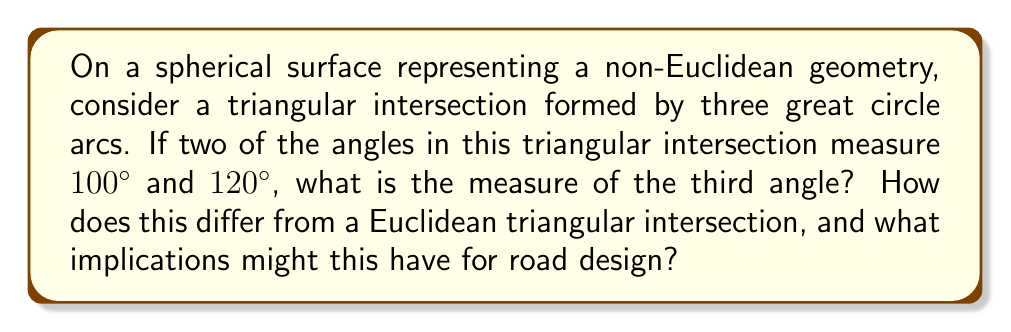Show me your answer to this math problem. Let's approach this step-by-step:

1) In spherical geometry, the sum of angles in a triangle is always greater than 180°. The formula for the angle sum of a spherical triangle is:

   $$ \text{Angle Sum} = 180° + A $$

   where $A$ is the area of the triangle in steradians multiplied by $\frac{180°}{\pi}$.

2) Let's denote the unknown angle as $x$. We know that:

   $$ 100° + 120° + x > 180° $$

3) In fact, we can calculate $x$ precisely. The angle sum formula for a spherical triangle is:

   $$ 100° + 120° + x = 180° + A $$

4) Simplifying:

   $$ 220° + x = 180° + A $$
   $$ x = (180° + A) - 220° = A - 40° $$

5) The exact value of $A$ depends on the size of the triangle on the sphere. However, we know that $A > 0°$, so:

   $$ x > -40° $$

6) Since angles must be positive, we can conclude that:

   $$ x > 0° $$

7) This means that the third angle must be positive, and the sum of the three angles will exceed 180°.

8) In contrast, in Euclidean geometry, the sum of angles in a triangle is always exactly 180°. If this were a Euclidean triangle, the third angle would be:

   $$ x = 180° - (100° + 120°) = -40° $$

   Which is impossible for a real triangle.

9) Implications for road design:
   - In spherical geometry, road intersections forming triangles will have angle sums greater than 180°.
   - This could affect sight lines, turning angles, and overall layout of intersections on large-scale road networks.
   - Engineers must account for these non-Euclidean properties when designing roads on a global scale or in areas where Earth's curvature is significant.
Answer: The third angle is positive and equal to $A - 40°$, where $A > 40°$ is the spherical excess of the triangle. 